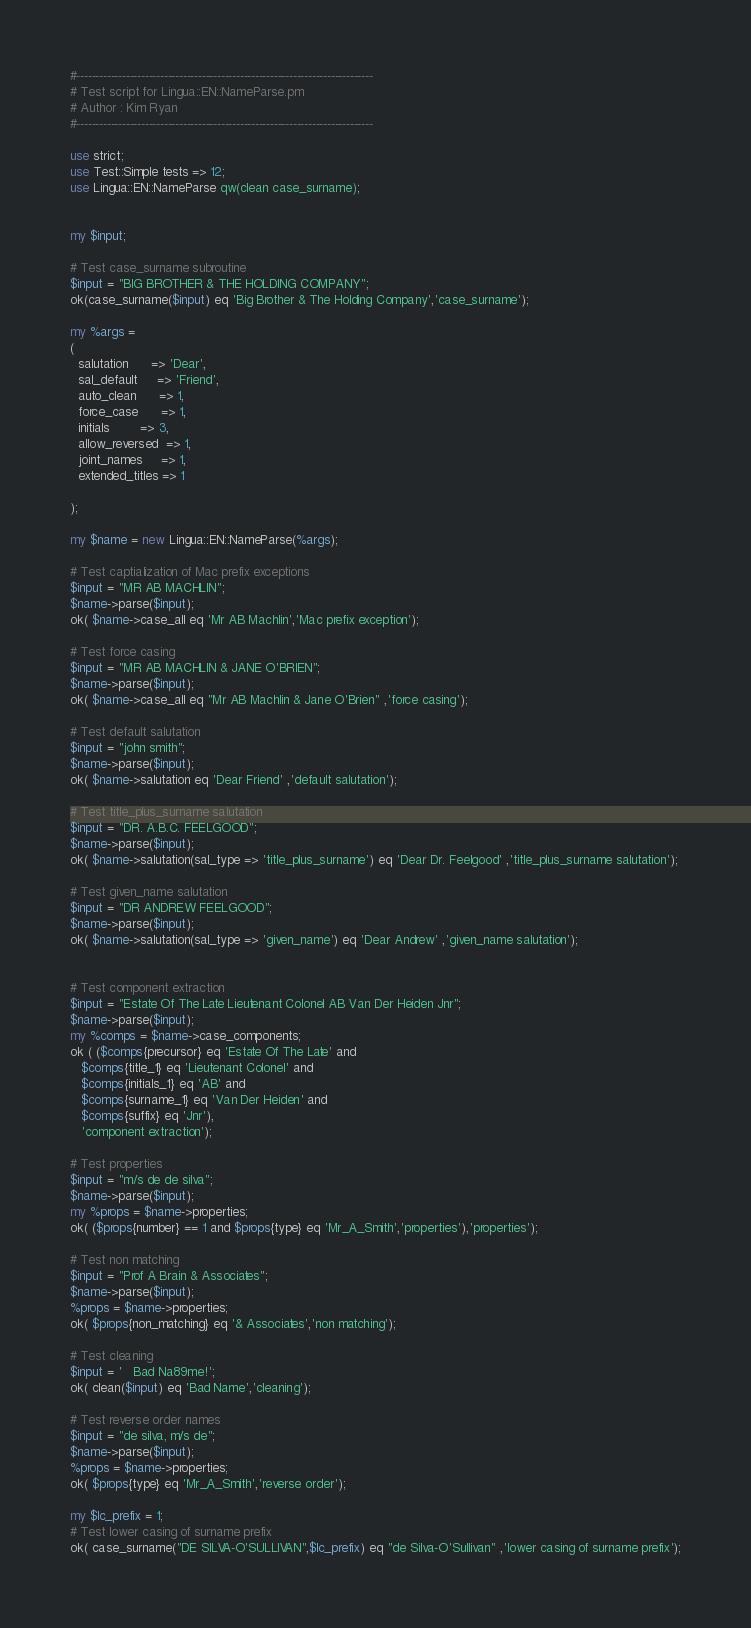<code> <loc_0><loc_0><loc_500><loc_500><_Perl_>#------------------------------------------------------------------------------
# Test script for Lingua::EN::NameParse.pm
# Author : Kim Ryan
#------------------------------------------------------------------------------

use strict;
use Test::Simple tests => 12;
use Lingua::EN::NameParse qw(clean case_surname);


my $input;

# Test case_surname subroutine
$input = "BIG BROTHER & THE HOLDING COMPANY";
ok(case_surname($input) eq 'Big Brother & The Holding Company','case_surname');

my %args =
(
  salutation      => 'Dear',
  sal_default     => 'Friend',
  auto_clean      => 1,
  force_case      => 1,
  initials        => 3,
  allow_reversed  => 1,
  joint_names     => 1,
  extended_titles => 1

);

my $name = new Lingua::EN::NameParse(%args);

# Test captialization of Mac prefix exceptions
$input = "MR AB MACHLIN";
$name->parse($input);
ok( $name->case_all eq 'Mr AB Machlin','Mac prefix exception');

# Test force casing
$input = "MR AB MACHLIN & JANE O'BRIEN";
$name->parse($input);
ok( $name->case_all eq "Mr AB Machlin & Jane O'Brien" ,'force casing');

# Test default salutation
$input = "john smith";
$name->parse($input);
ok( $name->salutation eq 'Dear Friend' ,'default salutation');

# Test title_plus_surname salutation
$input = "DR. A.B.C. FEELGOOD";
$name->parse($input);
ok( $name->salutation(sal_type => 'title_plus_surname') eq 'Dear Dr. Feelgood' ,'title_plus_surname salutation');

# Test given_name salutation
$input = "DR ANDREW FEELGOOD";
$name->parse($input);
ok( $name->salutation(sal_type => 'given_name') eq 'Dear Andrew' ,'given_name salutation');


# Test component extraction
$input = "Estate Of The Late Lieutenant Colonel AB Van Der Heiden Jnr";
$name->parse($input);
my %comps = $name->case_components;
ok ( ($comps{precursor} eq 'Estate Of The Late' and
   $comps{title_1} eq 'Lieutenant Colonel' and
   $comps{initials_1} eq 'AB' and
   $comps{surname_1} eq 'Van Der Heiden' and
   $comps{suffix} eq 'Jnr'),
   'component extraction');

# Test properties
$input = "m/s de de silva";
$name->parse($input);
my %props = $name->properties;
ok( ($props{number} == 1 and $props{type} eq 'Mr_A_Smith','properties'),'properties');

# Test non matching
$input = "Prof A Brain & Associates";
$name->parse($input);
%props = $name->properties;
ok( $props{non_matching} eq '& Associates','non matching');

# Test cleaning
$input = '   Bad Na89me!';
ok( clean($input) eq 'Bad Name','cleaning');

# Test reverse order names
$input = "de silva, m/s de";
$name->parse($input);
%props = $name->properties;
ok( $props{type} eq 'Mr_A_Smith','reverse order');

my $lc_prefix = 1;
# Test lower casing of surname prefix
ok( case_surname("DE SILVA-O'SULLIVAN",$lc_prefix) eq "de Silva-O'Sullivan" ,'lower casing of surname prefix');
</code> 